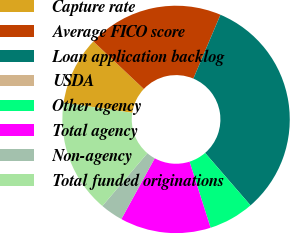<chart> <loc_0><loc_0><loc_500><loc_500><pie_chart><fcel>Capture rate<fcel>Average FICO score<fcel>Loan application backlog<fcel>USDA<fcel>Other agency<fcel>Total agency<fcel>Non-agency<fcel>Total funded originations<nl><fcel>9.68%<fcel>19.35%<fcel>32.26%<fcel>0.0%<fcel>6.45%<fcel>12.9%<fcel>3.23%<fcel>16.13%<nl></chart> 